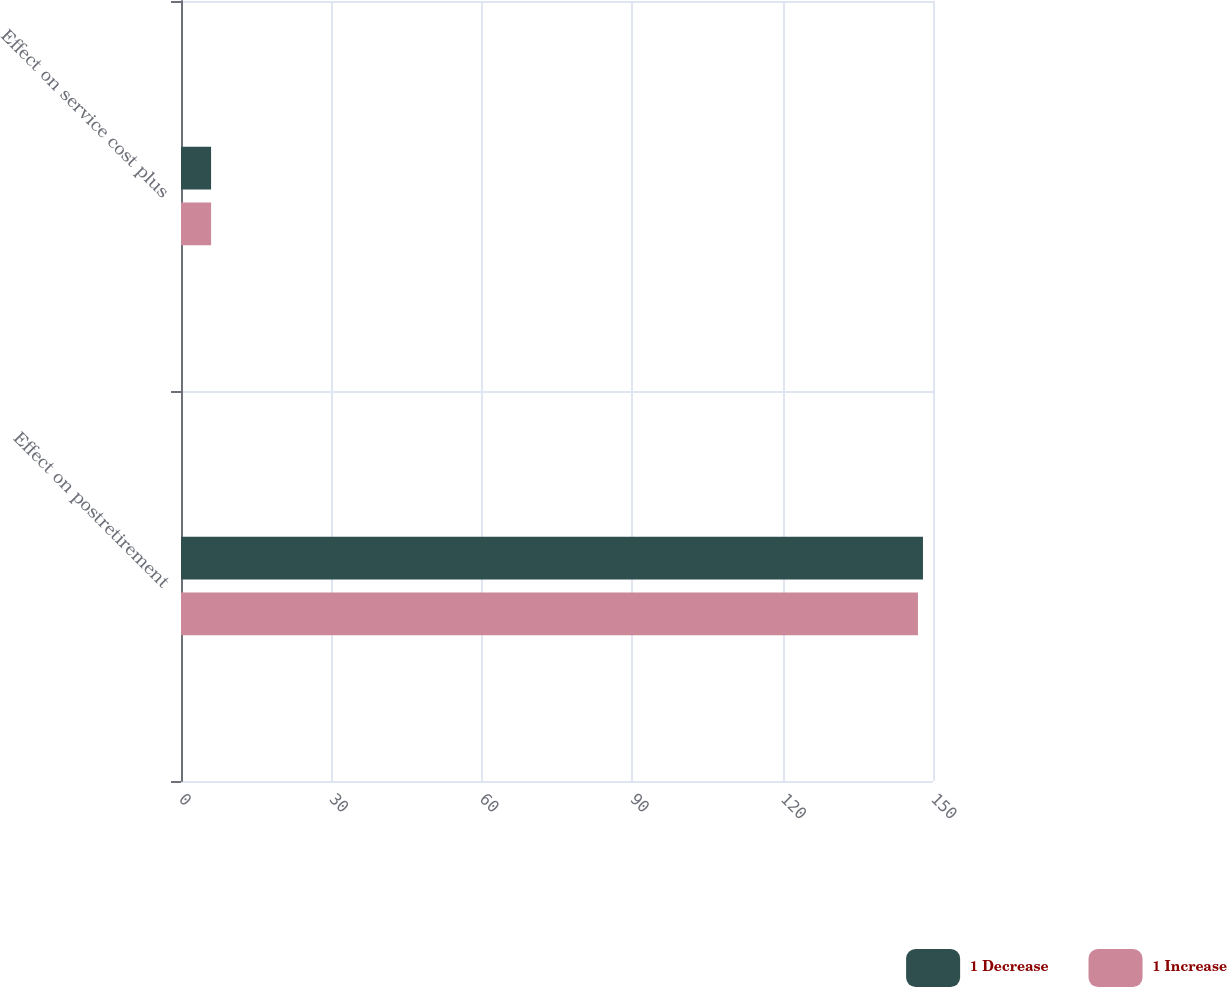<chart> <loc_0><loc_0><loc_500><loc_500><stacked_bar_chart><ecel><fcel>Effect on postretirement<fcel>Effect on service cost plus<nl><fcel>1 Decrease<fcel>148<fcel>6<nl><fcel>1 Increase<fcel>147<fcel>6<nl></chart> 